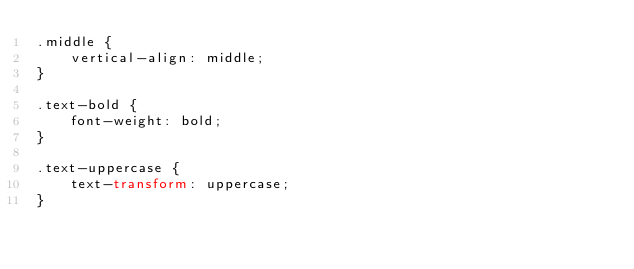<code> <loc_0><loc_0><loc_500><loc_500><_CSS_>.middle {
    vertical-align: middle;
}

.text-bold {
    font-weight: bold;
}

.text-uppercase {
    text-transform: uppercase;
}</code> 